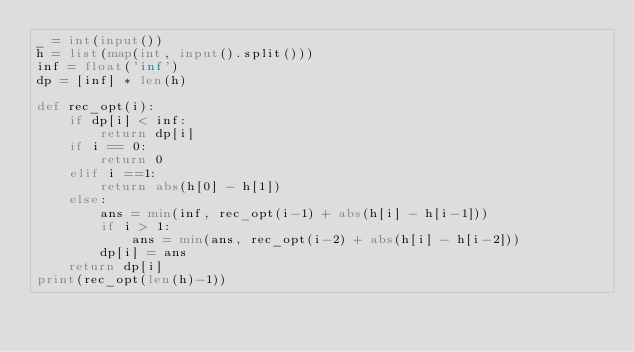Convert code to text. <code><loc_0><loc_0><loc_500><loc_500><_Python_>_ = int(input())
h = list(map(int, input().split()))
inf = float('inf')
dp = [inf] * len(h)

def rec_opt(i):
    if dp[i] < inf:
        return dp[i]
    if i == 0:
        return 0
    elif i ==1:
        return abs(h[0] - h[1])
    else:
        ans = min(inf, rec_opt(i-1) + abs(h[i] - h[i-1]))
        if i > 1:
            ans = min(ans, rec_opt(i-2) + abs(h[i] - h[i-2]))
        dp[i] = ans
    return dp[i]
print(rec_opt(len(h)-1))</code> 